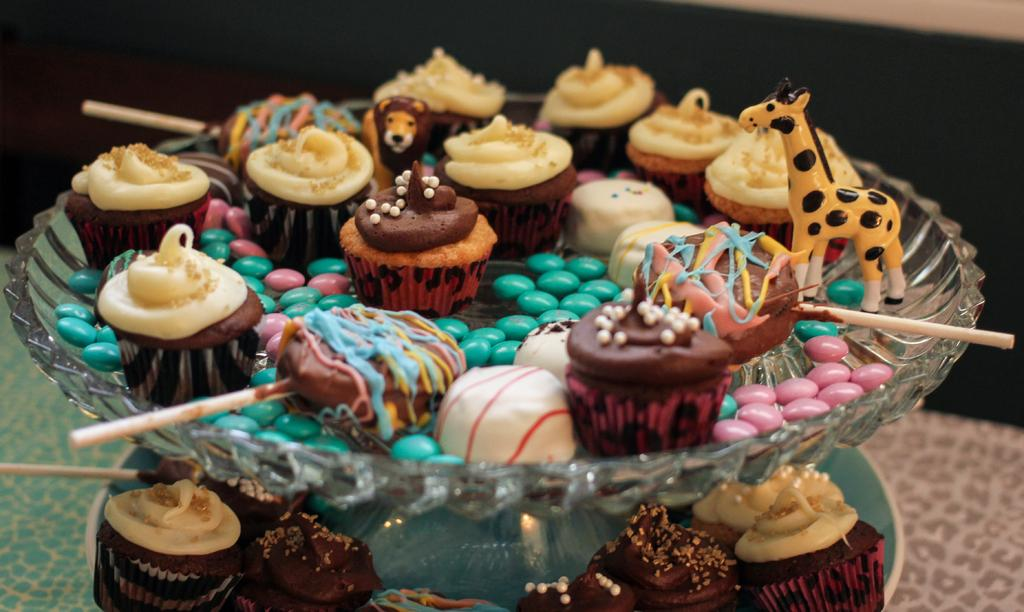What type of food items are in the image? There are cupcakes, gems, and lollipops in the image. How are these items arranged in the image? The items are in a bowl. Where is the bowl located in the image? The bowl is placed on a table. What type of metal is present in the image? There is no specific metal mentioned in the image; however, the gems could potentially be made of various materials, including metals like zinc. Can you describe the physical activity of the person in the image? There is no person present in the image, so it is impossible to describe any physical activity. 